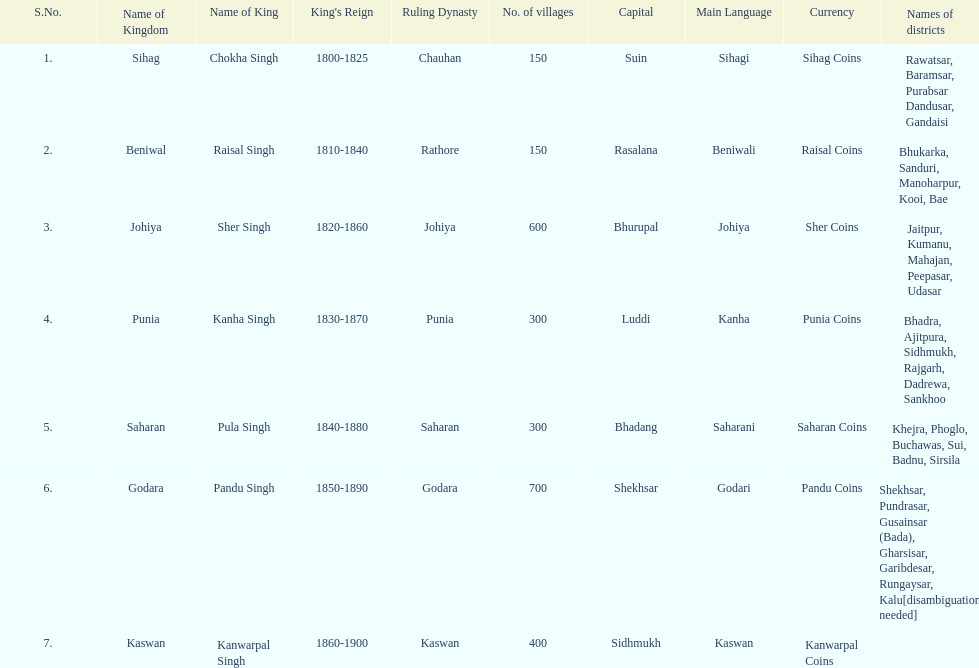Does punia have more or less villages than godara? Less. 